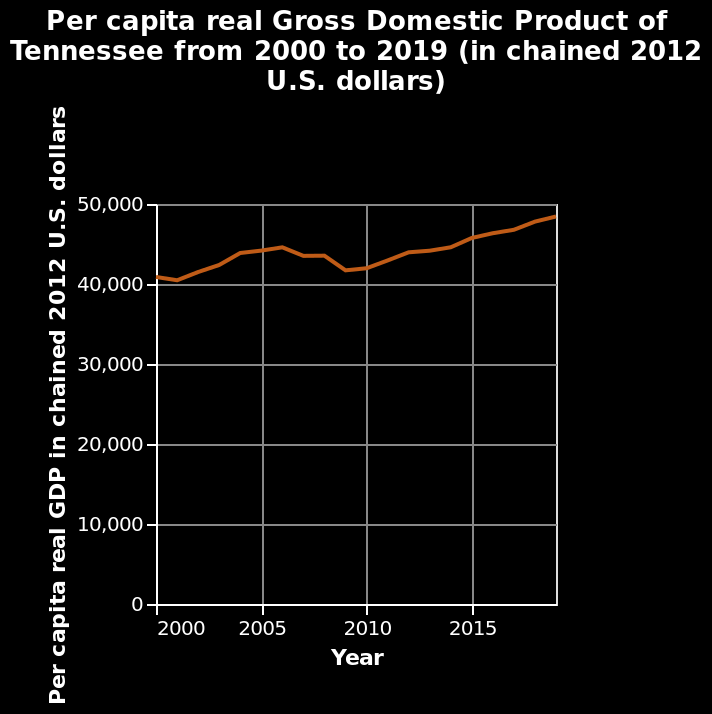<image>
Offer a thorough analysis of the image. The per capita GDP of Tennessee has never fallen below 40,000 chained 2012 US dollars between 2000-2019. It has fluctuated between 40,000 and 50,000 chained 2012 US dollars between 2000-2019, not quite reaching 50,000. 